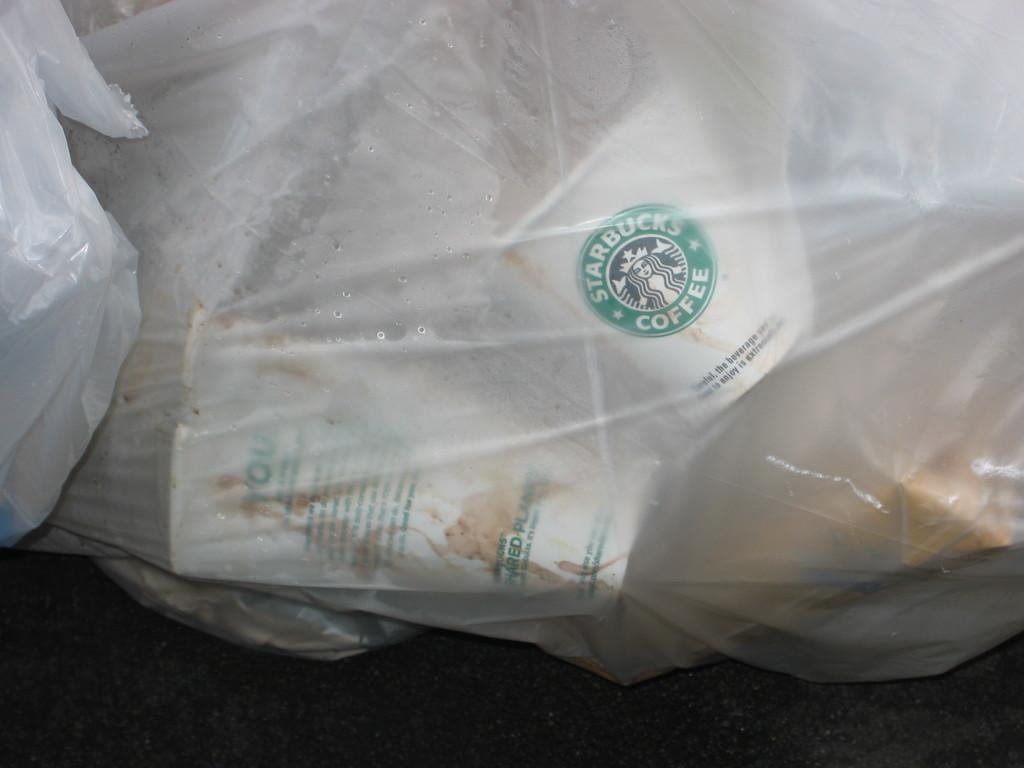What objects are covered in the image? There are covers in the image. What is inside the covers? There are disposable cups inside the covers. What can be seen on the cups? There is text and a picture of a woman on the cups. What is the surface at the bottom of the image? The bottom of the image appears to be a floor. Can you tell me how many chess pieces are on the floor in the image? There are no chess pieces visible in the image; it features covers with disposable cups inside. What type of porter is shown carrying the cups in the image? There is no porter present in the image; it only shows the cups and covers. 